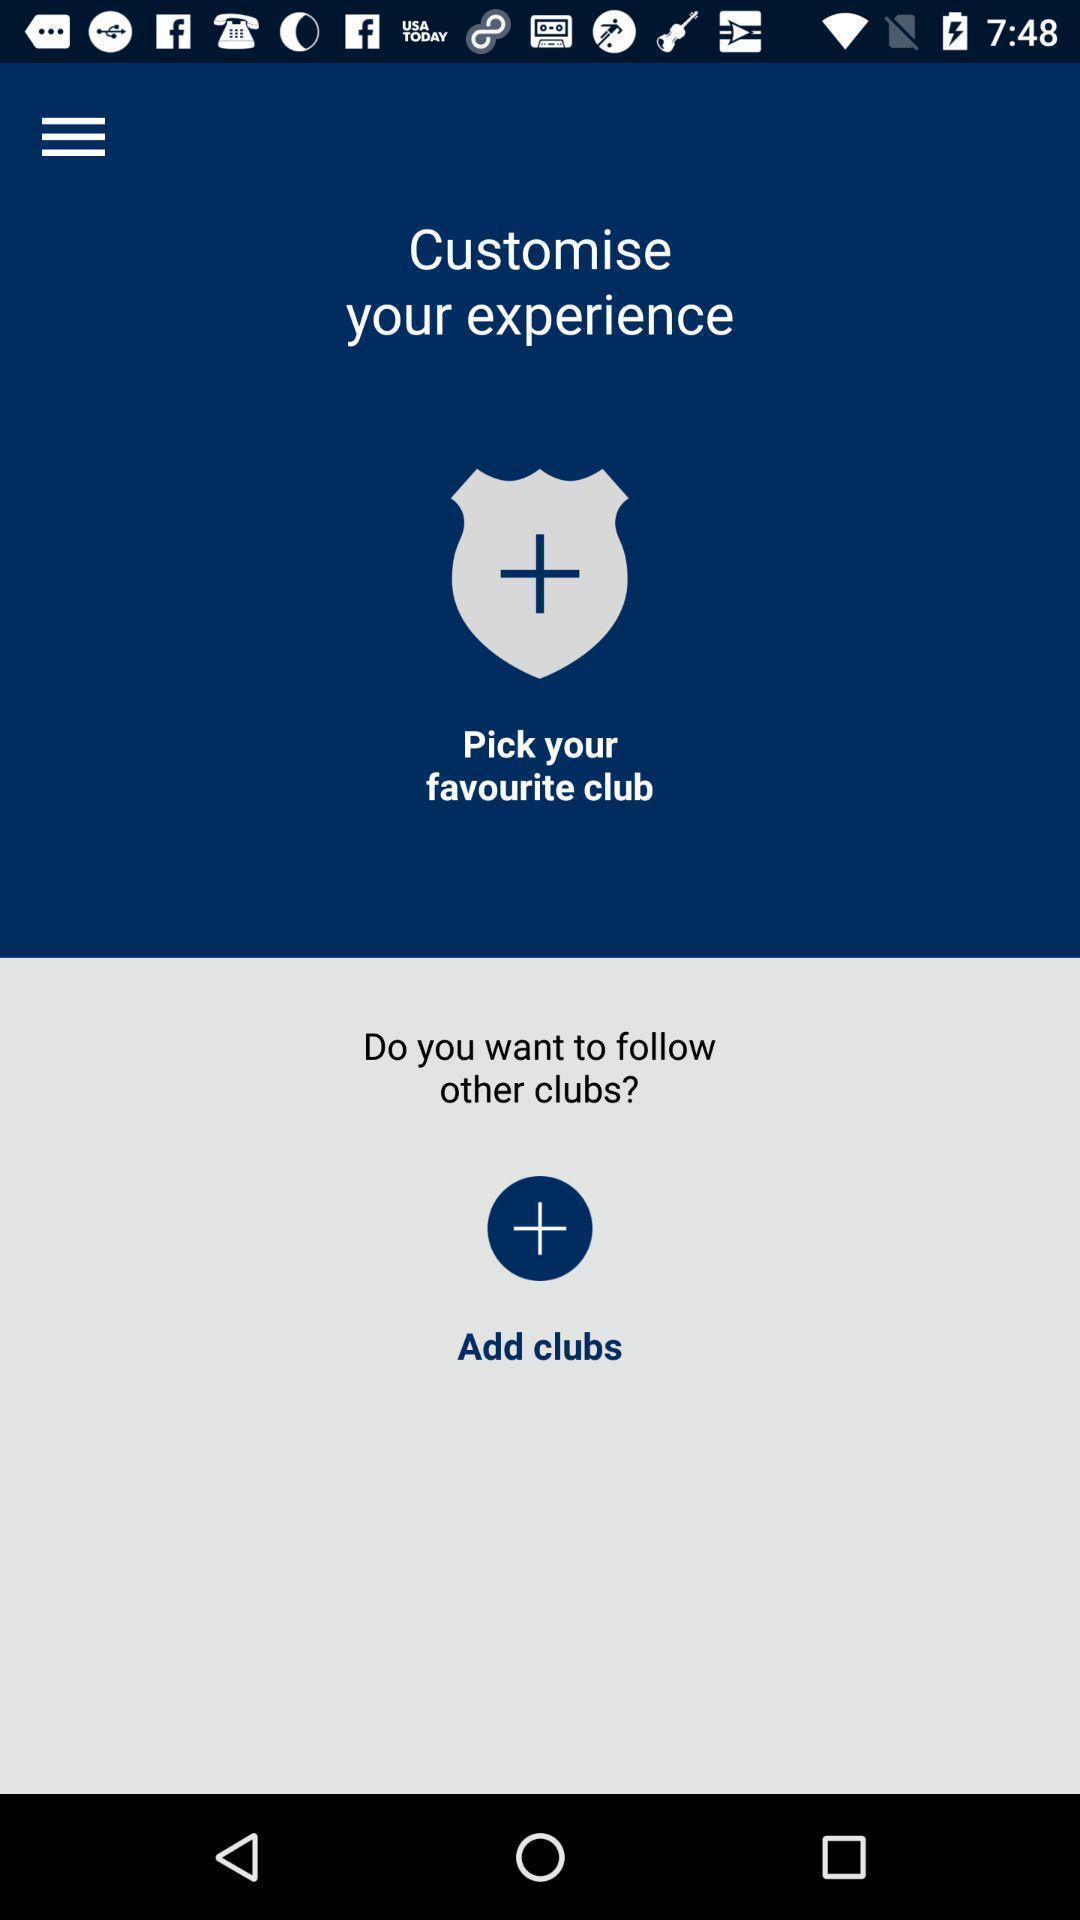Describe the key features of this screenshot. Welcome page. 